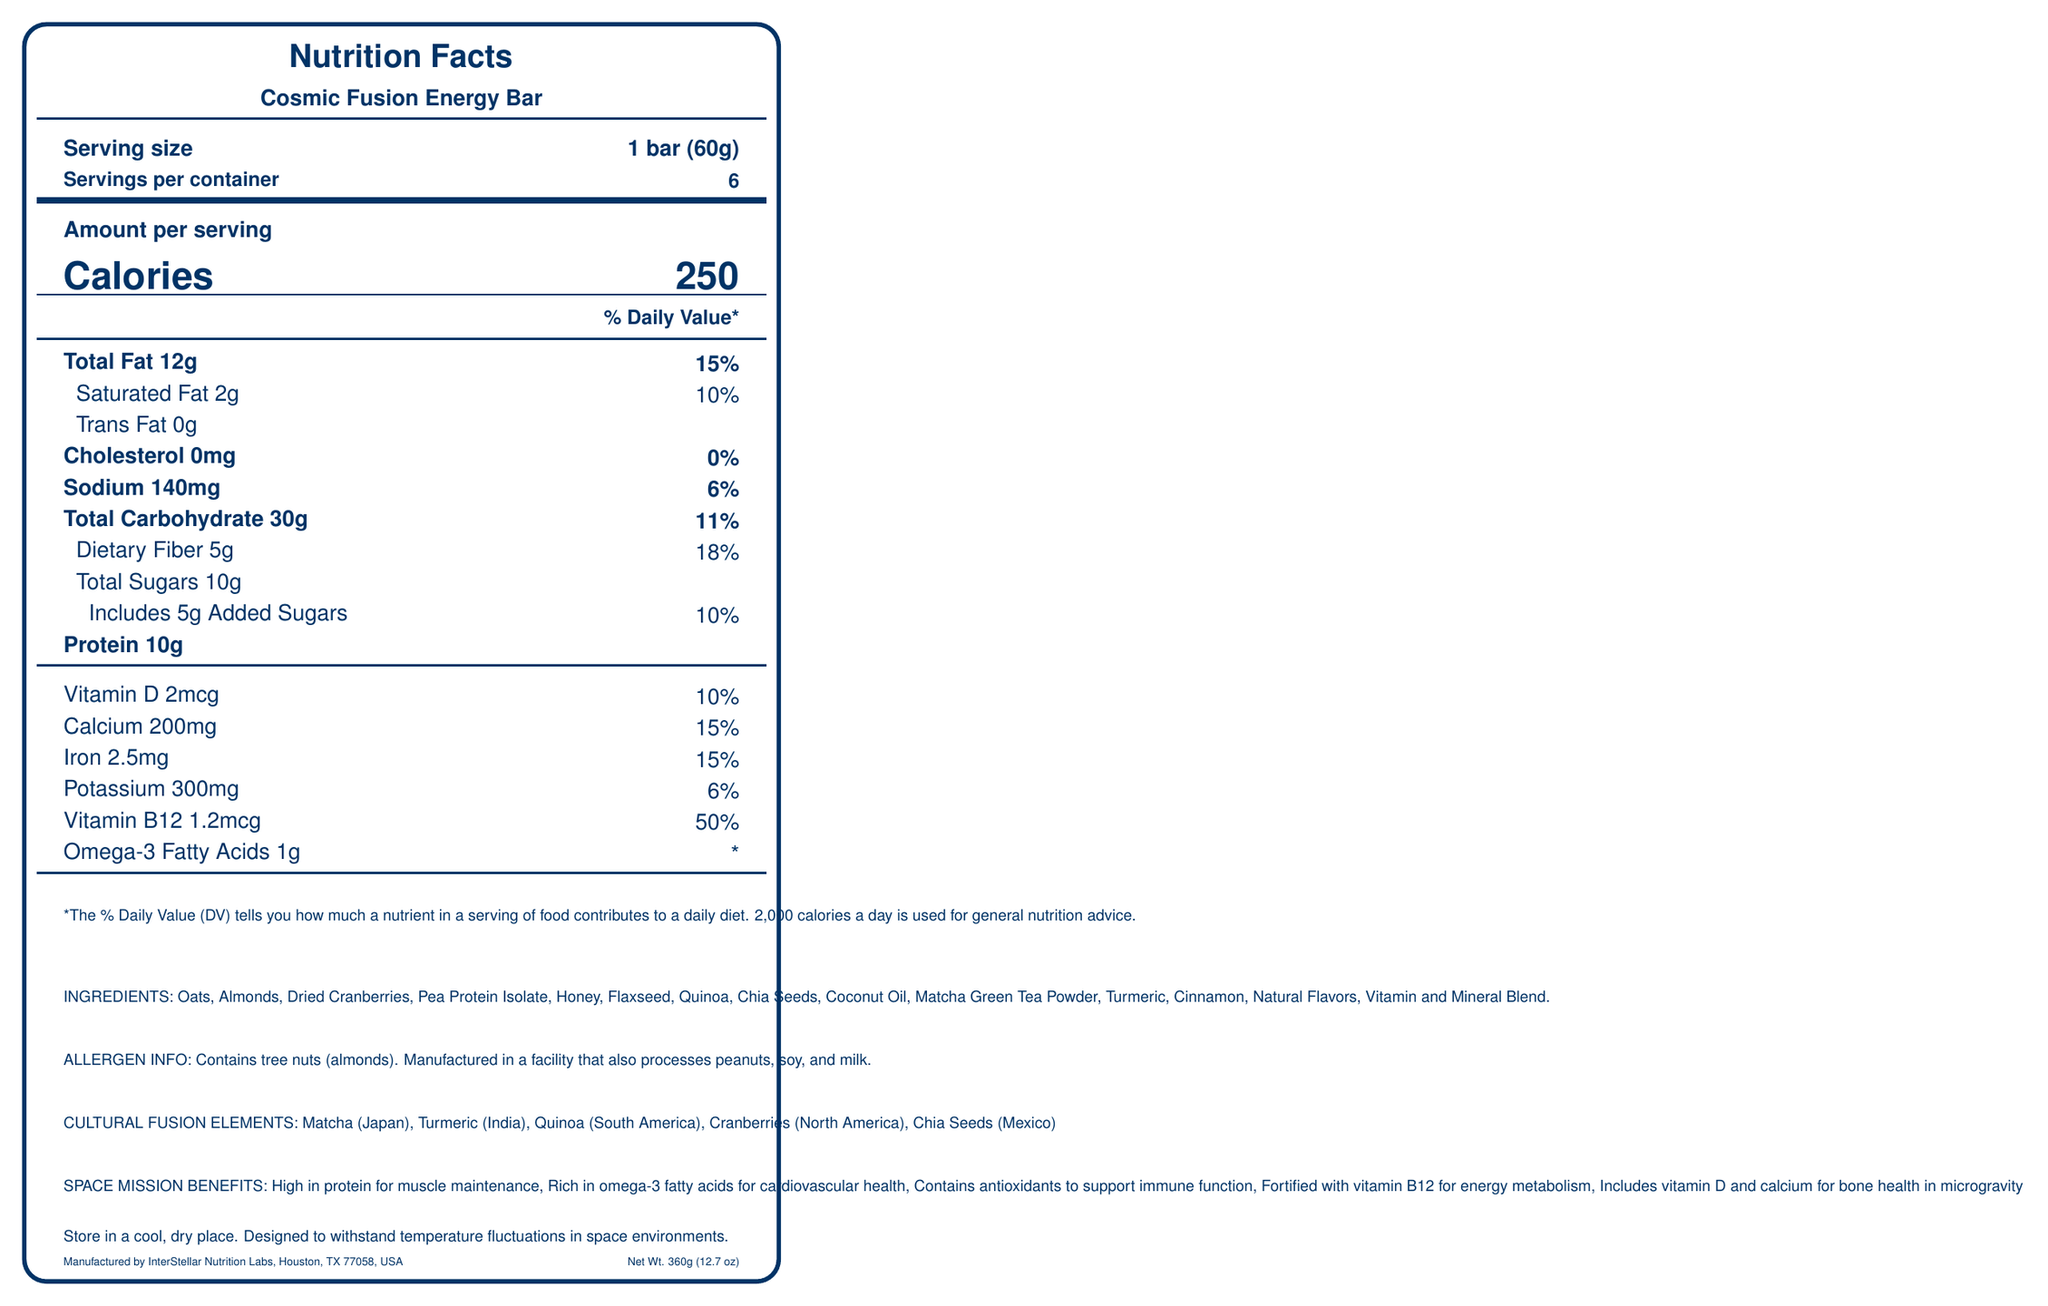What is the serving size of the Cosmic Fusion Energy Bar? The serving size is explicitly stated as "1 bar (60g)" in the Nutrition Facts section of the document.
Answer: 1 bar (60g) How many calories are in one serving of the Cosmic Fusion Energy Bar? The document directly lists the calorie count per serving as 250 calories.
Answer: 250 Which ingredient provides a Japanese cultural fusion element in the bar? The document notes that Matcha (Japan) is one of the Cultural Fusion Elements contained in the bar.
Answer: Matcha Name three benefits of this energy bar for space missions. The document lists these specific space mission benefits under "SPACE MISSION BENEFITS."
Answer: High in protein for muscle maintenance, Rich in omega-3 fatty acids for cardiovascular health, Contains antioxidants to support immune function What is the total amount of sugar, including added sugars, in a single serving? The total sugars are listed as 10g, which includes 5g of added sugars.
Answer: 10g (total sugars) What percentage of the daily value of Vitamin B12 does one serving provide? The document specifies that 1.2mcg of Vitamin B12 amounts to 50% of the daily value.
Answer: 50% How much Omega-3 fatty acids are in one serving of the bar? The document lists that there are 1g of Omega-3 fatty acids per serving.
Answer: 1g What is the amount of dietary fiber per serving? A. 3g B. 5g C. 7g D. 10g The document specifies that there are 5g of dietary fiber per serving, which is 18% of the daily value.
Answer: B. 5g What is the total number of servings per container? A. 3 B. 6 C. 9 D. 12 The document clearly lists that there are 6 servings per container.
Answer: B. 6 Is there any cholesterol in the Cosmic Fusion Energy Bar? Yes/No The document specifies that the bar contains 0mg of cholesterol, which is 0% of the daily value.
Answer: No Describe the main idea of this document. The document aims to inform about the nutritional content, cultural significance, and benefits of the Cosmic Fusion Energy Bar, making it suitable for space missions and promoting cross-cultural exchange.
Answer: The document provides detailed nutritional information for the Cosmic Fusion Energy Bar, including serving size, calories, and individual nutrients. It highlights cultural fusion ingredients from various countries and outlines benefits for space missions. Storage instructions and allergen information are also included. Where is the Cosmic Fusion Energy Bar manufactured? The document includes this information at the bottom, stating the manufacturer and location.
Answer: InterStellar Nutrition Labs, Houston, TX 77058, USA What is the cultural fusion element from Mexico included in the bar? The document specifies "Chia Seeds (Mexico)" as one of the cultural fusion ingredients.
Answer: Chia Seeds What is the daily value percentage of calcium in one serving? The document lists that 200mg of calcium contributes 15% to the daily value.
Answer: 15% What is not sufficient in terms of visual information in the document? The document doesn't specify a specific shelf life or expiration date for the energy bar.
Answer: How long can the bar be stored. 